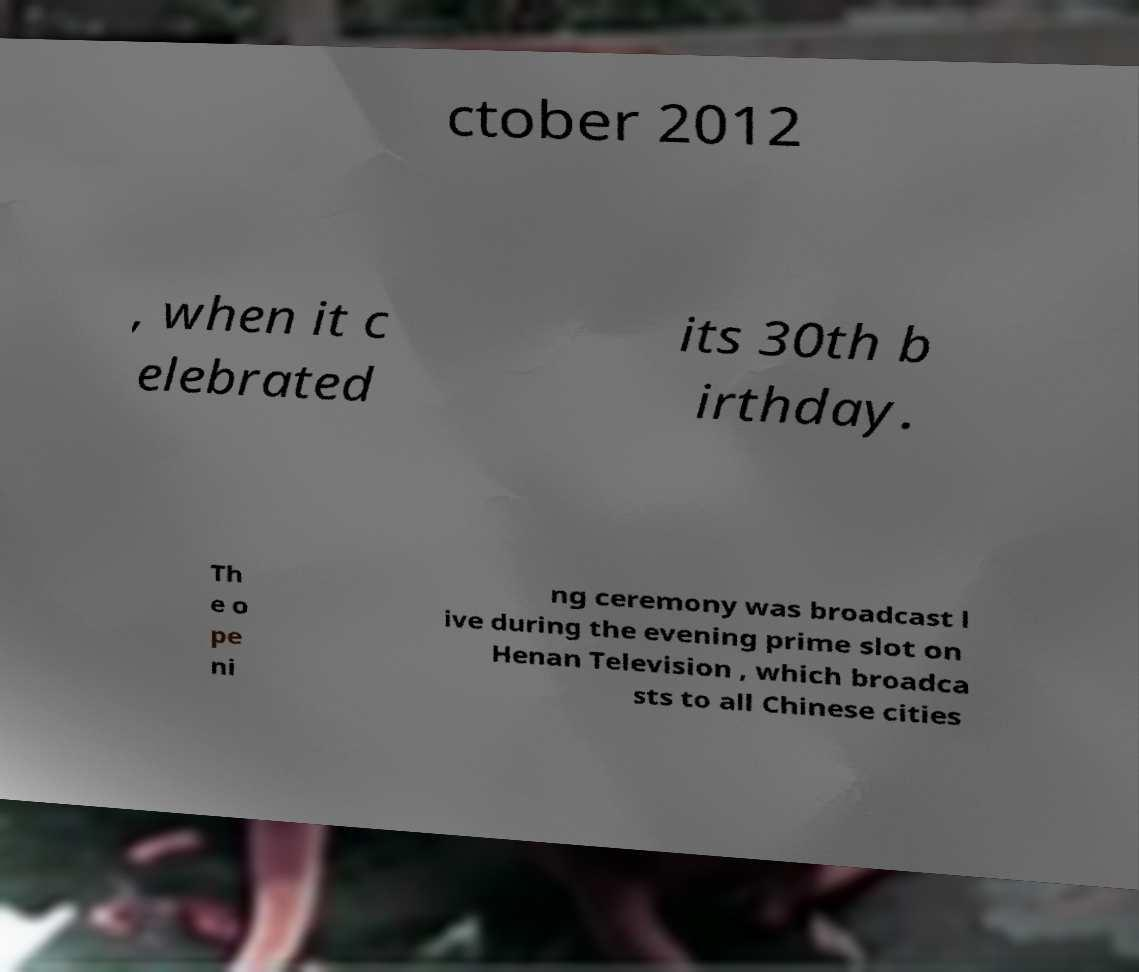Could you extract and type out the text from this image? ctober 2012 , when it c elebrated its 30th b irthday. Th e o pe ni ng ceremony was broadcast l ive during the evening prime slot on Henan Television , which broadca sts to all Chinese cities 